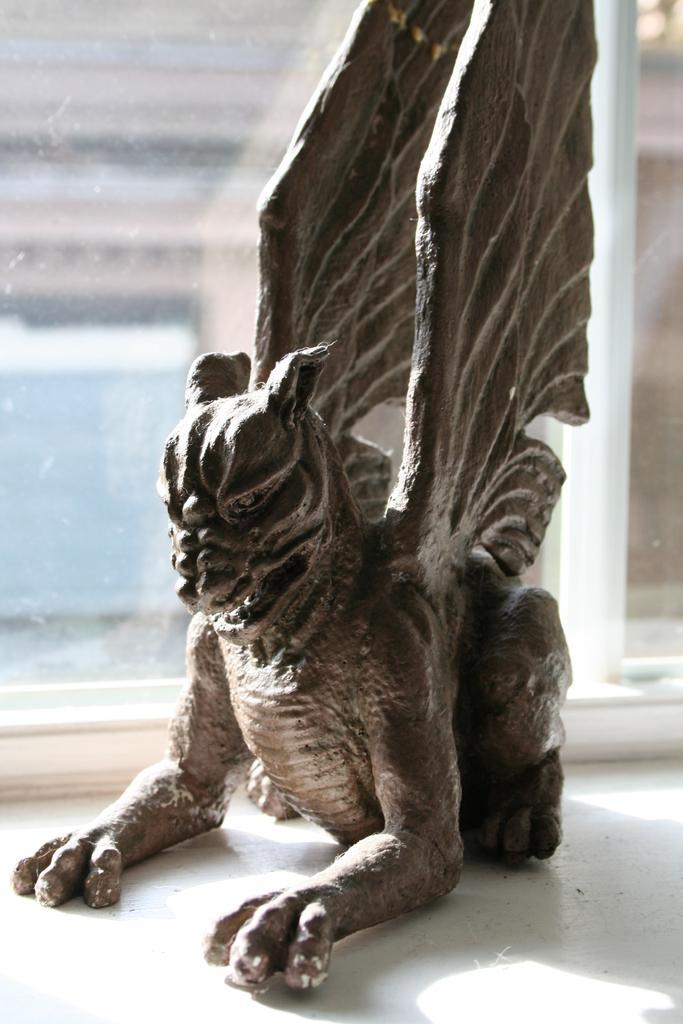Could you give a brief overview of what you see in this image? In this image we can see a statue of an animal containing wings to it. In the background we can see a window. 